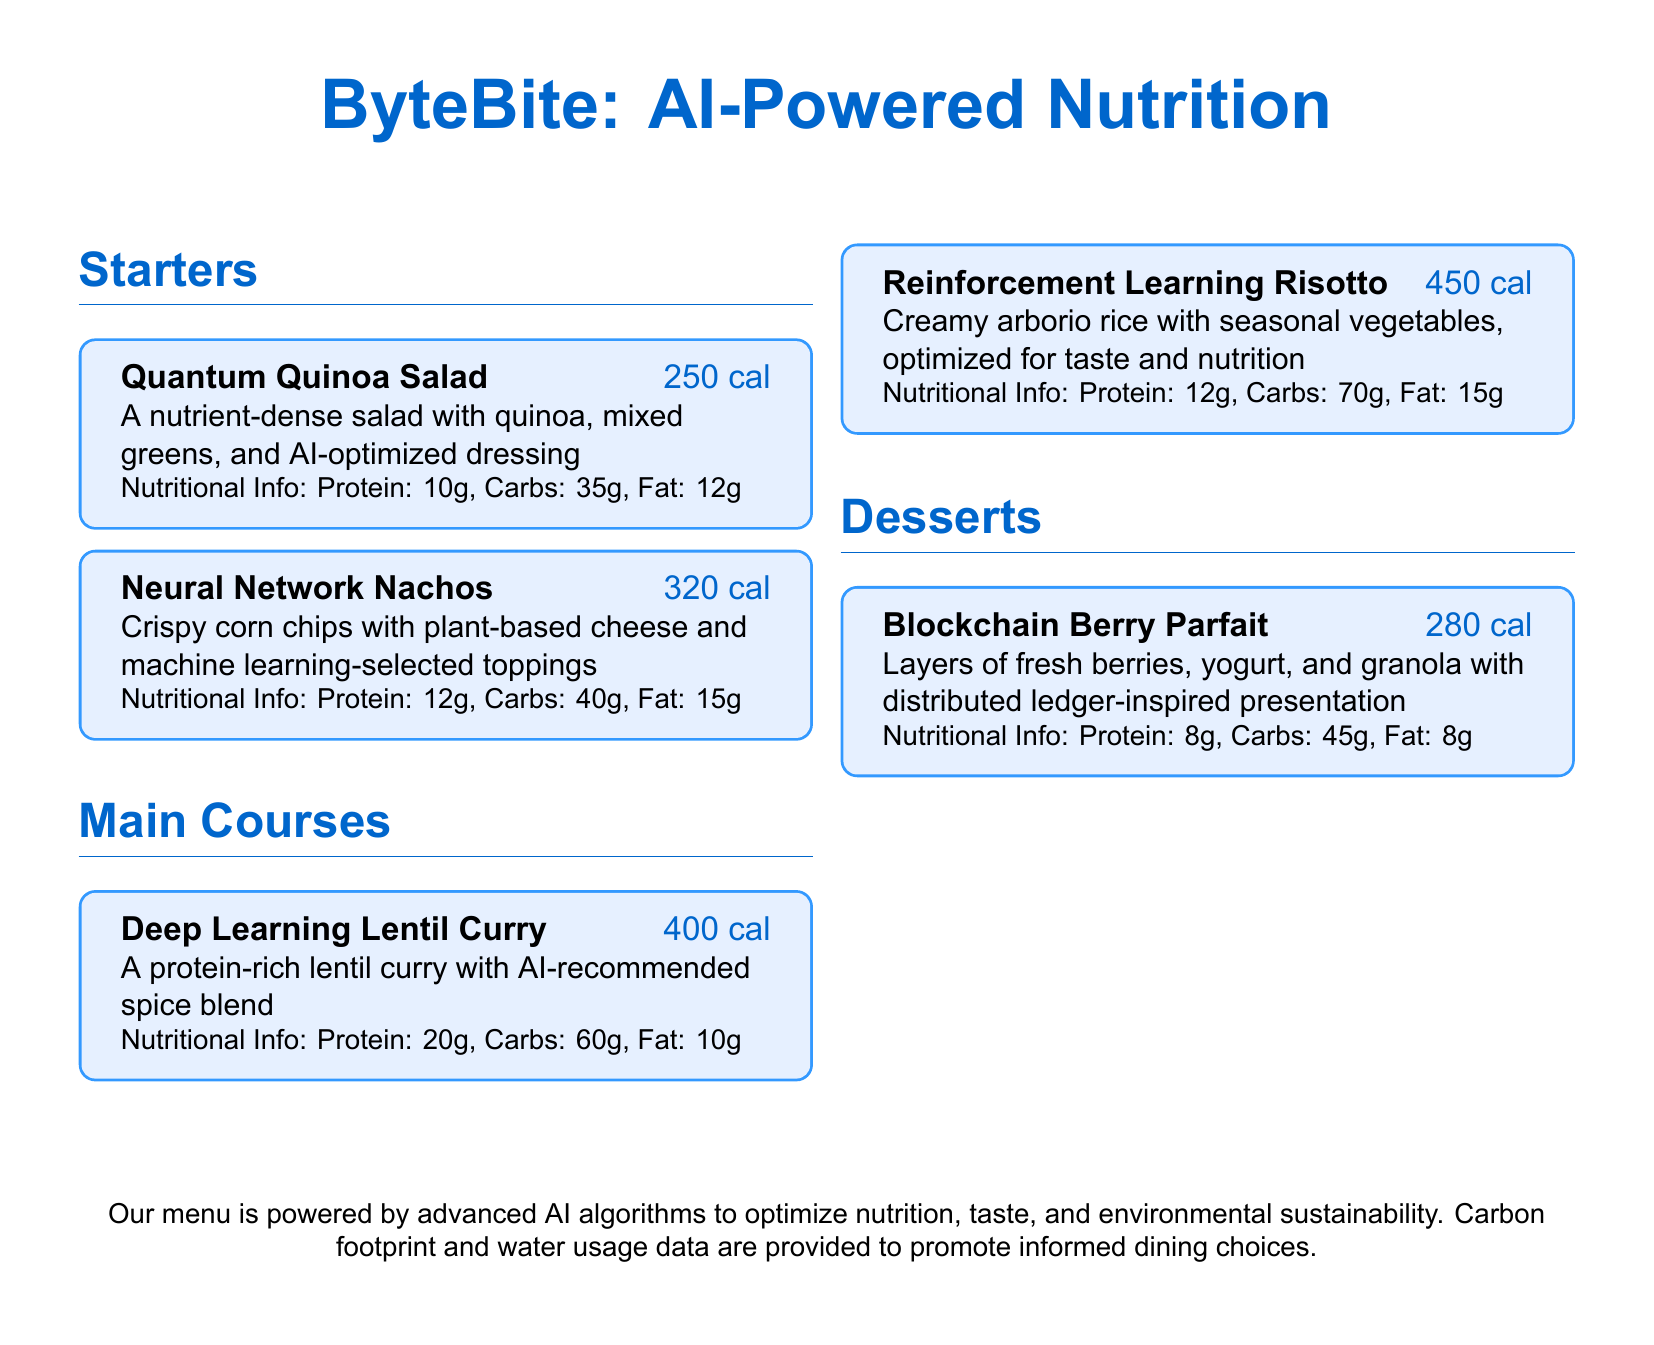What is the calorie count of Quantum Quinoa Salad? The calorie count is mentioned directly with the menu item, which is 250 calories.
Answer: 250 cal What main course has the highest calorie count? Comparing the calorie counts of the main courses, Reinforcement Learning Risotto has the highest at 450 calories.
Answer: Reinforcement Learning Risotto How many grams of protein are in Neural Network Nachos? The protein content is listed for each dish, with Neural Network Nachos containing 12 grams.
Answer: 12g What type of dressing is used in Quantum Quinoa Salad? The dressing type is described as AI-optimized, which refers to its nutritional optimization via AI algorithms.
Answer: AI-optimized dressing What dessert features fresh berries? The dessert named Blockchain Berry Parfait specifically mentions layers of fresh berries as a key ingredient.
Answer: Blockchain Berry Parfait Which dish is described as a protein-rich meal? The Deep Learning Lentil Curry is explicitly noted to be protein-rich in its description.
Answer: Deep Learning Lentil Curry What is the total fat content of Reinforcement Learning Risotto? The total fat content listed for Reinforcement Learning Risotto is 15 grams.
Answer: 15g How is the presentation of Blockchain Berry Parfait described? The presentation style is inspired by distributed ledger technology, indicating a unique visual arrangement.
Answer: Distributed ledger-inspired presentation 